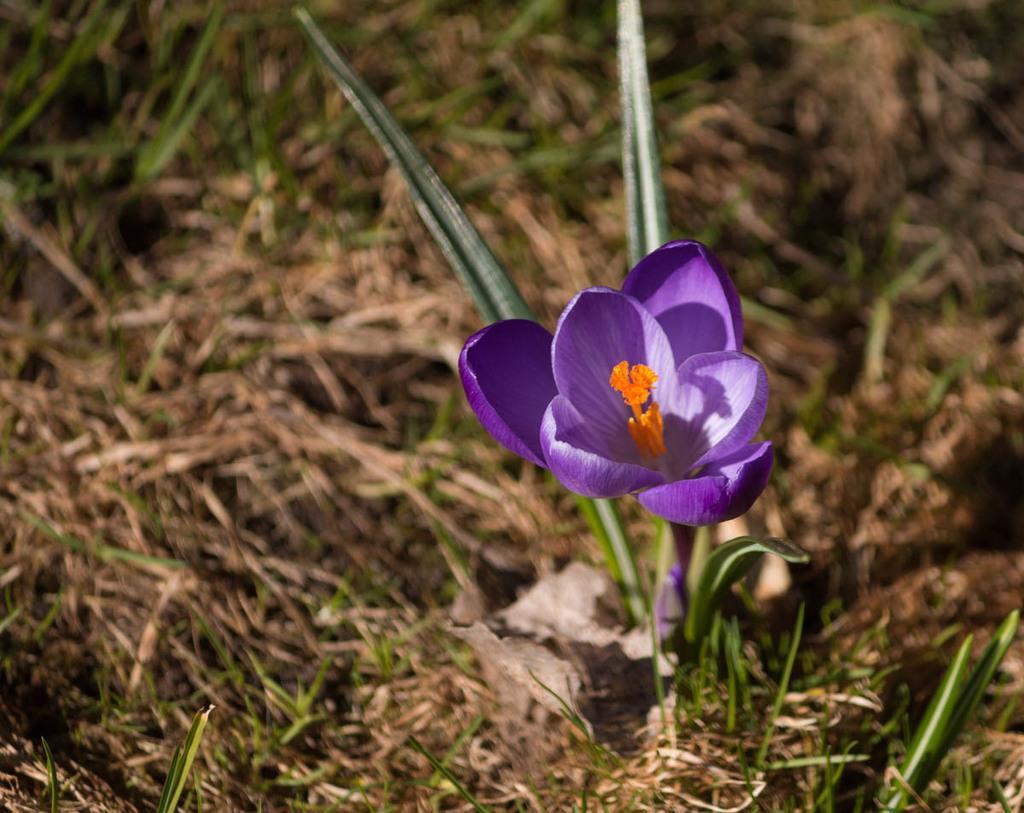Could you give a brief overview of what you see in this image? In this picture there is a flower which is in violet and orange color on the ground. We can observe some grass and plants on the ground. 